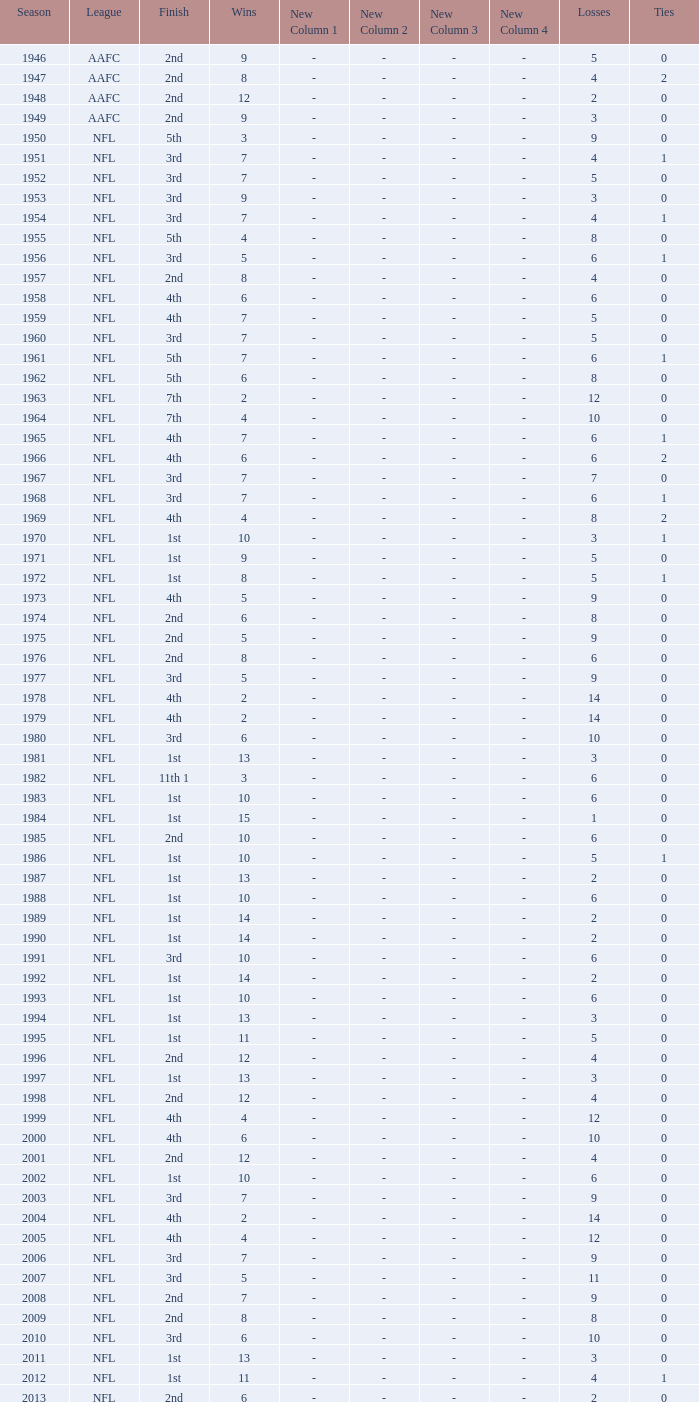What league had a finish of 2nd and 3 losses? AAFC. 